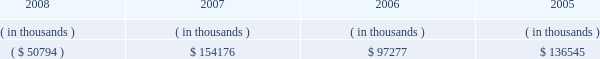Entergy texas , inc .
Management's financial discussion and analysis dividends or other distributions on its common stock .
Currently , all of entergy texas' retained earnings are available for distribution .
Sources of capital entergy texas' sources to meet its capital requirements include : internally generated funds ; cash on hand ; debt or preferred stock issuances ; and bank financing under new or existing facilities .
Entergy texas may refinance or redeem debt prior to maturity , to the extent market conditions and interest and dividend rates are favorable .
All debt and common and preferred stock issuances by entergy texas require prior regulatory approval .
Preferred stock and debt issuances are also subject to issuance tests set forth in its corporate charter , bond indentures , and other agreements .
Entergy texas has sufficient capacity under these tests to meet its foreseeable capital needs .
Entergy gulf states , inc .
Filed with the ferc an application , on behalf of entergy texas , for authority to issue up to $ 200 million of short-term debt , up to $ 300 million of tax-exempt bonds , and up to $ 1.3 billion of other long- term securities , including common and preferred or preference stock and long-term debt .
On november 8 , 2007 , the ferc issued orders granting the requested authority for a two-year period ending november 8 , 2009 .
Entergy texas' receivables from or ( payables to ) the money pool were as follows as of december 31 for each of the following years: .
See note 4 to the financial statements for a description of the money pool .
Entergy texas has a credit facility in the amount of $ 100 million scheduled to expire in august 2012 .
As of december 31 , 2008 , $ 100 million was outstanding on the credit facility .
In february 2009 , entergy texas repaid its credit facility with the proceeds from the bond issuance discussed below .
On june 2 , 2008 and december 8 , 2008 , under the terms of the debt assumption agreement between entergy texas and entergy gulf states louisiana that is discussed in note 5 to the financial statements , entergy texas paid at maturity $ 148.8 million and $ 160.3 million , respectively , of entergy gulf states louisiana first mortgage bonds , which results in a corresponding decrease in entergy texas' debt assumption liability .
In december 2008 , entergy texas borrowed $ 160 million from its parent company , entergy corporation , under a $ 300 million revolving credit facility pursuant to an inter-company credit agreement between entergy corporation and entergy texas .
This borrowing would have matured on december 3 , 2013 .
Entergy texas used these borrowings , together with other available corporate funds , to pay at maturity the portion of the $ 350 million floating rate series of first mortgage bonds due december 2008 that had been assumed by entergy texas , and that bond series is no longer outstanding .
In january 2009 , entergy texas repaid its $ 160 million note payable to entergy corporation with the proceeds from the bond issuance discussed below .
In january 2009 , entergy texas issued $ 500 million of 7.125% ( 7.125 % ) series mortgage bonds due february 2019 .
Entergy texas used a portion of the proceeds to repay its $ 160 million note payable to entergy corporation , to repay the $ 100 million outstanding on its credit facility , and to repay short-term borrowings under the entergy system money pool .
Entergy texas intends to use the remaining proceeds to repay on or prior to maturity approximately $ 70 million of obligations that had been assumed by entergy texas under the debt assumption agreement with entergy gulf states louisiana and for other general corporate purposes. .
How much of entergy gulf states louisiana first mortgage bonds , in millions of dollars , were paid by entergy texas in total? 
Computations: (148.8 + 160.3)
Answer: 309.1. 